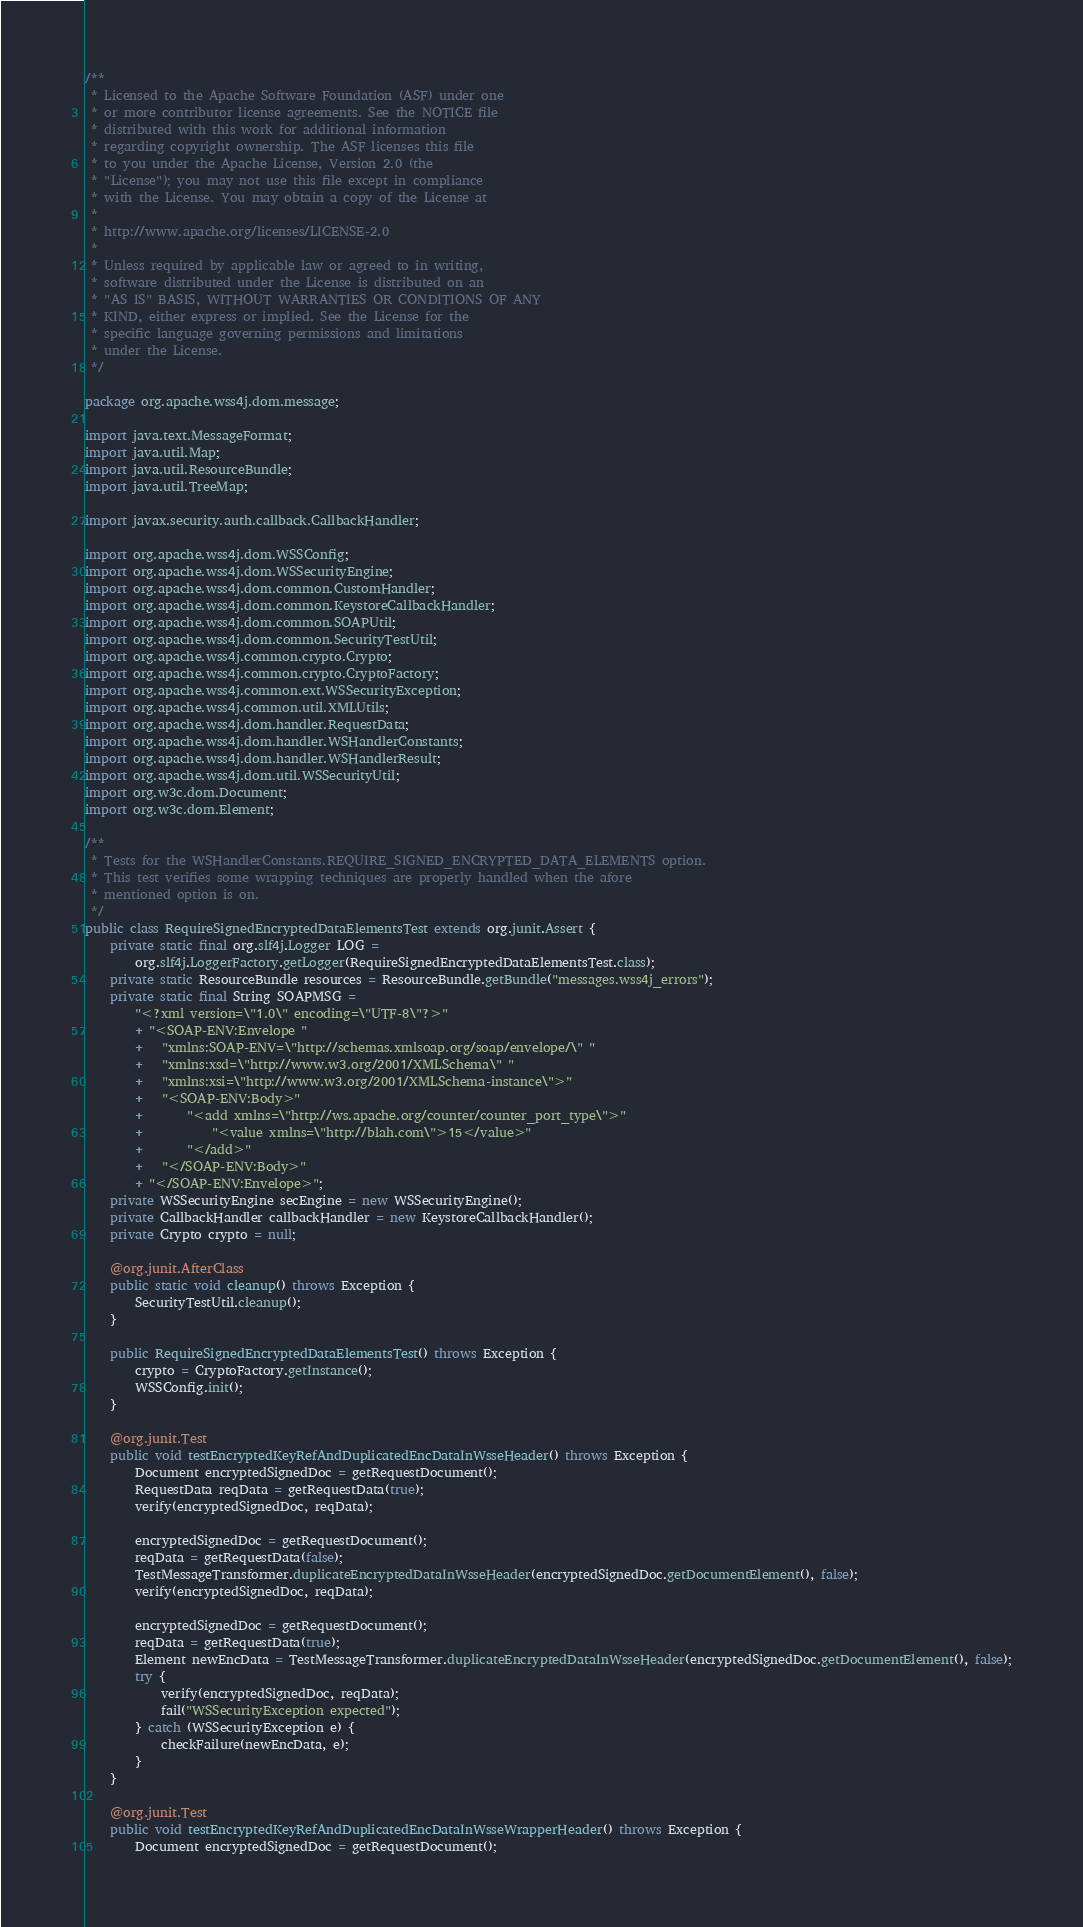Convert code to text. <code><loc_0><loc_0><loc_500><loc_500><_Java_>/**
 * Licensed to the Apache Software Foundation (ASF) under one
 * or more contributor license agreements. See the NOTICE file
 * distributed with this work for additional information
 * regarding copyright ownership. The ASF licenses this file
 * to you under the Apache License, Version 2.0 (the
 * "License"); you may not use this file except in compliance
 * with the License. You may obtain a copy of the License at
 *
 * http://www.apache.org/licenses/LICENSE-2.0
 *
 * Unless required by applicable law or agreed to in writing,
 * software distributed under the License is distributed on an
 * "AS IS" BASIS, WITHOUT WARRANTIES OR CONDITIONS OF ANY
 * KIND, either express or implied. See the License for the
 * specific language governing permissions and limitations
 * under the License.
 */

package org.apache.wss4j.dom.message;

import java.text.MessageFormat;
import java.util.Map;
import java.util.ResourceBundle;
import java.util.TreeMap;

import javax.security.auth.callback.CallbackHandler;

import org.apache.wss4j.dom.WSSConfig;
import org.apache.wss4j.dom.WSSecurityEngine;
import org.apache.wss4j.dom.common.CustomHandler;
import org.apache.wss4j.dom.common.KeystoreCallbackHandler;
import org.apache.wss4j.dom.common.SOAPUtil;
import org.apache.wss4j.dom.common.SecurityTestUtil;
import org.apache.wss4j.common.crypto.Crypto;
import org.apache.wss4j.common.crypto.CryptoFactory;
import org.apache.wss4j.common.ext.WSSecurityException;
import org.apache.wss4j.common.util.XMLUtils;
import org.apache.wss4j.dom.handler.RequestData;
import org.apache.wss4j.dom.handler.WSHandlerConstants;
import org.apache.wss4j.dom.handler.WSHandlerResult;
import org.apache.wss4j.dom.util.WSSecurityUtil;
import org.w3c.dom.Document;
import org.w3c.dom.Element;

/**
 * Tests for the WSHandlerConstants.REQUIRE_SIGNED_ENCRYPTED_DATA_ELEMENTS option.
 * This test verifies some wrapping techniques are properly handled when the afore
 * mentioned option is on.
 */
public class RequireSignedEncryptedDataElementsTest extends org.junit.Assert {
    private static final org.slf4j.Logger LOG = 
        org.slf4j.LoggerFactory.getLogger(RequireSignedEncryptedDataElementsTest.class);
    private static ResourceBundle resources = ResourceBundle.getBundle("messages.wss4j_errors");
    private static final String SOAPMSG = 
        "<?xml version=\"1.0\" encoding=\"UTF-8\"?>" 
        + "<SOAP-ENV:Envelope "
        +   "xmlns:SOAP-ENV=\"http://schemas.xmlsoap.org/soap/envelope/\" "
        +   "xmlns:xsd=\"http://www.w3.org/2001/XMLSchema\" "
        +   "xmlns:xsi=\"http://www.w3.org/2001/XMLSchema-instance\">" 
        +   "<SOAP-ENV:Body>" 
        +       "<add xmlns=\"http://ws.apache.org/counter/counter_port_type\">" 
        +           "<value xmlns=\"http://blah.com\">15</value>" 
        +       "</add>" 
        +   "</SOAP-ENV:Body>" 
        + "</SOAP-ENV:Envelope>";
    private WSSecurityEngine secEngine = new WSSecurityEngine();
    private CallbackHandler callbackHandler = new KeystoreCallbackHandler();
    private Crypto crypto = null;

    @org.junit.AfterClass
    public static void cleanup() throws Exception {
        SecurityTestUtil.cleanup();
    }
    
    public RequireSignedEncryptedDataElementsTest() throws Exception {
        crypto = CryptoFactory.getInstance();
        WSSConfig.init();
    }

    @org.junit.Test
    public void testEncryptedKeyRefAndDuplicatedEncDataInWsseHeader() throws Exception {
        Document encryptedSignedDoc = getRequestDocument();
        RequestData reqData = getRequestData(true);
        verify(encryptedSignedDoc, reqData);
        
        encryptedSignedDoc = getRequestDocument();
        reqData = getRequestData(false);
        TestMessageTransformer.duplicateEncryptedDataInWsseHeader(encryptedSignedDoc.getDocumentElement(), false);
        verify(encryptedSignedDoc, reqData);
        
        encryptedSignedDoc = getRequestDocument();
        reqData = getRequestData(true);
        Element newEncData = TestMessageTransformer.duplicateEncryptedDataInWsseHeader(encryptedSignedDoc.getDocumentElement(), false);
        try {
            verify(encryptedSignedDoc, reqData);
            fail("WSSecurityException expected");
        } catch (WSSecurityException e) {
            checkFailure(newEncData, e);
        }
    }
    
    @org.junit.Test
    public void testEncryptedKeyRefAndDuplicatedEncDataInWsseWrapperHeader() throws Exception {
        Document encryptedSignedDoc = getRequestDocument();</code> 